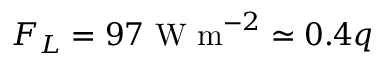<formula> <loc_0><loc_0><loc_500><loc_500>F _ { L } = 9 7 W m ^ { - 2 } \simeq 0 . 4 q</formula> 